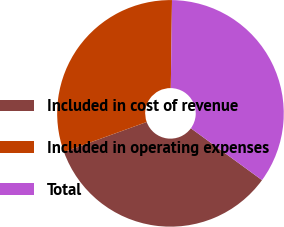Convert chart. <chart><loc_0><loc_0><loc_500><loc_500><pie_chart><fcel>Included in cost of revenue<fcel>Included in operating expenses<fcel>Total<nl><fcel>34.44%<fcel>30.75%<fcel>34.81%<nl></chart> 